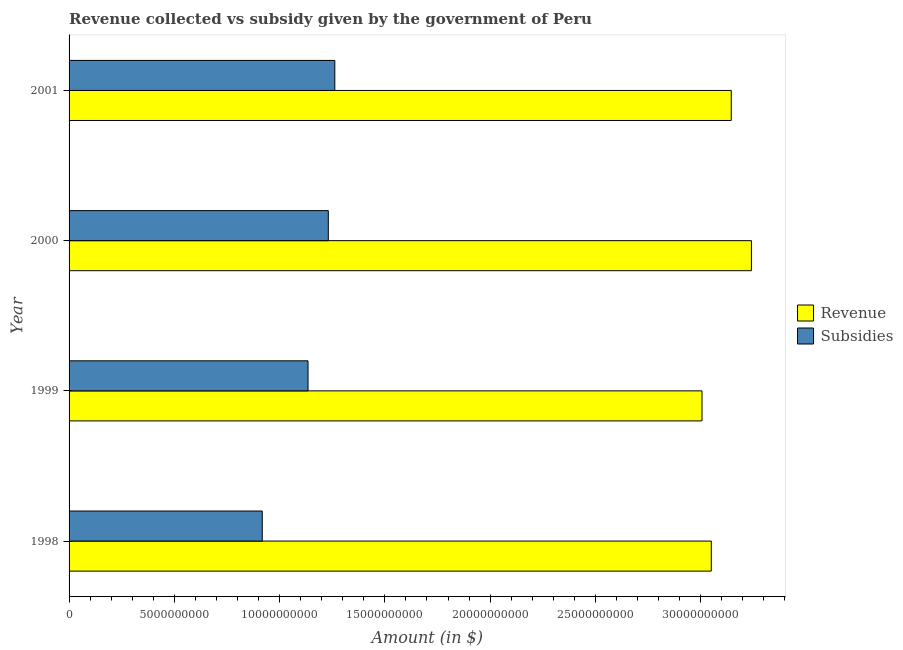How many different coloured bars are there?
Ensure brevity in your answer.  2. Are the number of bars per tick equal to the number of legend labels?
Make the answer very short. Yes. Are the number of bars on each tick of the Y-axis equal?
Your response must be concise. Yes. How many bars are there on the 3rd tick from the top?
Your response must be concise. 2. In how many cases, is the number of bars for a given year not equal to the number of legend labels?
Offer a very short reply. 0. What is the amount of subsidies given in 1998?
Provide a succinct answer. 9.18e+09. Across all years, what is the maximum amount of revenue collected?
Your answer should be very brief. 3.24e+1. Across all years, what is the minimum amount of subsidies given?
Your answer should be very brief. 9.18e+09. In which year was the amount of revenue collected maximum?
Your answer should be very brief. 2000. In which year was the amount of subsidies given minimum?
Provide a short and direct response. 1998. What is the total amount of subsidies given in the graph?
Your answer should be compact. 4.55e+1. What is the difference between the amount of subsidies given in 1999 and that in 2001?
Provide a succinct answer. -1.27e+09. What is the difference between the amount of revenue collected in 2000 and the amount of subsidies given in 1998?
Your answer should be compact. 2.32e+1. What is the average amount of subsidies given per year?
Give a very brief answer. 1.14e+1. In the year 1998, what is the difference between the amount of subsidies given and amount of revenue collected?
Keep it short and to the point. -2.13e+1. What is the ratio of the amount of subsidies given in 2000 to that in 2001?
Provide a succinct answer. 0.98. Is the amount of revenue collected in 1999 less than that in 2000?
Give a very brief answer. Yes. What is the difference between the highest and the second highest amount of revenue collected?
Provide a succinct answer. 9.58e+08. What is the difference between the highest and the lowest amount of revenue collected?
Keep it short and to the point. 2.35e+09. In how many years, is the amount of subsidies given greater than the average amount of subsidies given taken over all years?
Give a very brief answer. 2. What does the 2nd bar from the top in 1998 represents?
Your answer should be compact. Revenue. What does the 2nd bar from the bottom in 2001 represents?
Provide a succinct answer. Subsidies. Are all the bars in the graph horizontal?
Your answer should be compact. Yes. How many years are there in the graph?
Make the answer very short. 4. Does the graph contain any zero values?
Ensure brevity in your answer.  No. Does the graph contain grids?
Offer a very short reply. No. What is the title of the graph?
Give a very brief answer. Revenue collected vs subsidy given by the government of Peru. What is the label or title of the X-axis?
Make the answer very short. Amount (in $). What is the Amount (in $) in Revenue in 1998?
Offer a terse response. 3.05e+1. What is the Amount (in $) in Subsidies in 1998?
Give a very brief answer. 9.18e+09. What is the Amount (in $) of Revenue in 1999?
Provide a succinct answer. 3.01e+1. What is the Amount (in $) in Subsidies in 1999?
Offer a very short reply. 1.13e+1. What is the Amount (in $) in Revenue in 2000?
Give a very brief answer. 3.24e+1. What is the Amount (in $) in Subsidies in 2000?
Ensure brevity in your answer.  1.23e+1. What is the Amount (in $) in Revenue in 2001?
Provide a short and direct response. 3.15e+1. What is the Amount (in $) of Subsidies in 2001?
Provide a short and direct response. 1.26e+1. Across all years, what is the maximum Amount (in $) in Revenue?
Make the answer very short. 3.24e+1. Across all years, what is the maximum Amount (in $) in Subsidies?
Keep it short and to the point. 1.26e+1. Across all years, what is the minimum Amount (in $) in Revenue?
Ensure brevity in your answer.  3.01e+1. Across all years, what is the minimum Amount (in $) of Subsidies?
Make the answer very short. 9.18e+09. What is the total Amount (in $) of Revenue in the graph?
Keep it short and to the point. 1.24e+11. What is the total Amount (in $) in Subsidies in the graph?
Give a very brief answer. 4.55e+1. What is the difference between the Amount (in $) in Revenue in 1998 and that in 1999?
Provide a short and direct response. 4.41e+08. What is the difference between the Amount (in $) in Subsidies in 1998 and that in 1999?
Offer a very short reply. -2.17e+09. What is the difference between the Amount (in $) of Revenue in 1998 and that in 2000?
Ensure brevity in your answer.  -1.91e+09. What is the difference between the Amount (in $) in Subsidies in 1998 and that in 2000?
Your response must be concise. -3.14e+09. What is the difference between the Amount (in $) of Revenue in 1998 and that in 2001?
Your response must be concise. -9.47e+08. What is the difference between the Amount (in $) in Subsidies in 1998 and that in 2001?
Keep it short and to the point. -3.45e+09. What is the difference between the Amount (in $) of Revenue in 1999 and that in 2000?
Provide a short and direct response. -2.35e+09. What is the difference between the Amount (in $) in Subsidies in 1999 and that in 2000?
Your answer should be compact. -9.63e+08. What is the difference between the Amount (in $) of Revenue in 1999 and that in 2001?
Your response must be concise. -1.39e+09. What is the difference between the Amount (in $) in Subsidies in 1999 and that in 2001?
Keep it short and to the point. -1.27e+09. What is the difference between the Amount (in $) in Revenue in 2000 and that in 2001?
Offer a terse response. 9.58e+08. What is the difference between the Amount (in $) in Subsidies in 2000 and that in 2001?
Ensure brevity in your answer.  -3.09e+08. What is the difference between the Amount (in $) of Revenue in 1998 and the Amount (in $) of Subsidies in 1999?
Your answer should be compact. 1.92e+1. What is the difference between the Amount (in $) of Revenue in 1998 and the Amount (in $) of Subsidies in 2000?
Offer a terse response. 1.82e+1. What is the difference between the Amount (in $) of Revenue in 1998 and the Amount (in $) of Subsidies in 2001?
Provide a short and direct response. 1.79e+1. What is the difference between the Amount (in $) in Revenue in 1999 and the Amount (in $) in Subsidies in 2000?
Make the answer very short. 1.77e+1. What is the difference between the Amount (in $) in Revenue in 1999 and the Amount (in $) in Subsidies in 2001?
Keep it short and to the point. 1.74e+1. What is the difference between the Amount (in $) of Revenue in 2000 and the Amount (in $) of Subsidies in 2001?
Ensure brevity in your answer.  1.98e+1. What is the average Amount (in $) in Revenue per year?
Your answer should be compact. 3.11e+1. What is the average Amount (in $) of Subsidies per year?
Your response must be concise. 1.14e+1. In the year 1998, what is the difference between the Amount (in $) of Revenue and Amount (in $) of Subsidies?
Offer a terse response. 2.13e+1. In the year 1999, what is the difference between the Amount (in $) of Revenue and Amount (in $) of Subsidies?
Your answer should be compact. 1.87e+1. In the year 2000, what is the difference between the Amount (in $) of Revenue and Amount (in $) of Subsidies?
Your answer should be very brief. 2.01e+1. In the year 2001, what is the difference between the Amount (in $) of Revenue and Amount (in $) of Subsidies?
Give a very brief answer. 1.88e+1. What is the ratio of the Amount (in $) of Revenue in 1998 to that in 1999?
Make the answer very short. 1.01. What is the ratio of the Amount (in $) of Subsidies in 1998 to that in 1999?
Your response must be concise. 0.81. What is the ratio of the Amount (in $) of Subsidies in 1998 to that in 2000?
Provide a succinct answer. 0.75. What is the ratio of the Amount (in $) of Revenue in 1998 to that in 2001?
Provide a short and direct response. 0.97. What is the ratio of the Amount (in $) in Subsidies in 1998 to that in 2001?
Make the answer very short. 0.73. What is the ratio of the Amount (in $) in Revenue in 1999 to that in 2000?
Provide a succinct answer. 0.93. What is the ratio of the Amount (in $) of Subsidies in 1999 to that in 2000?
Offer a very short reply. 0.92. What is the ratio of the Amount (in $) of Revenue in 1999 to that in 2001?
Provide a short and direct response. 0.96. What is the ratio of the Amount (in $) in Subsidies in 1999 to that in 2001?
Give a very brief answer. 0.9. What is the ratio of the Amount (in $) of Revenue in 2000 to that in 2001?
Your response must be concise. 1.03. What is the ratio of the Amount (in $) in Subsidies in 2000 to that in 2001?
Keep it short and to the point. 0.98. What is the difference between the highest and the second highest Amount (in $) of Revenue?
Make the answer very short. 9.58e+08. What is the difference between the highest and the second highest Amount (in $) in Subsidies?
Provide a succinct answer. 3.09e+08. What is the difference between the highest and the lowest Amount (in $) of Revenue?
Your response must be concise. 2.35e+09. What is the difference between the highest and the lowest Amount (in $) in Subsidies?
Give a very brief answer. 3.45e+09. 